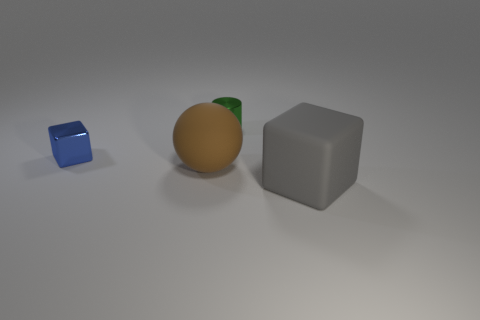Add 4 brown matte blocks. How many objects exist? 8 Subtract all gray metallic objects. Subtract all metallic cylinders. How many objects are left? 3 Add 4 tiny metal cylinders. How many tiny metal cylinders are left? 5 Add 4 large brown metallic cubes. How many large brown metallic cubes exist? 4 Subtract 1 green cylinders. How many objects are left? 3 